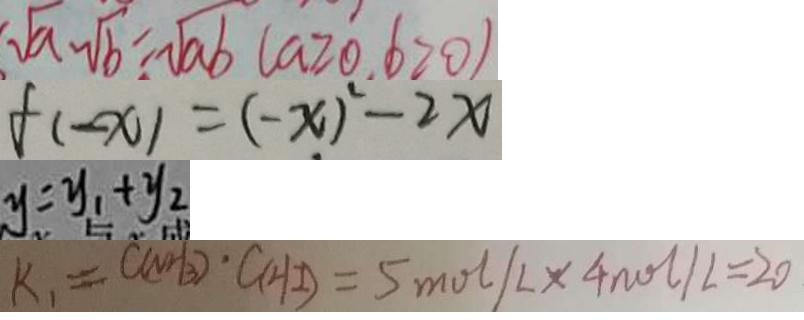<formula> <loc_0><loc_0><loc_500><loc_500>\sqrt { a } \cdot \sqrt { b } = \sqrt { a b } ( a \geq 0 , b > 0 ) 
 f ( - x ) = ( - x ) ^ { 2 } - 2 x 
 y = y _ { 1 } + y _ { 2 } 
 k _ { 1 } = C ( N H _ { 3 } ) \cdot C ( H I ) = 5 m o l / L \times 4 n o l / L = 2 0</formula> 